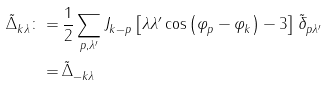<formula> <loc_0><loc_0><loc_500><loc_500>\tilde { \Delta } ^ { \ } _ { k \lambda } \colon = & \, \frac { 1 } { 2 } \sum _ { p , \lambda ^ { \prime } } J ^ { \ } _ { k - p } \left [ \lambda \lambda ^ { \prime } \cos \left ( \varphi ^ { \ } _ { p } - \varphi ^ { \ } _ { k } \right ) - 3 \right ] \tilde { \delta } ^ { \ } _ { p \lambda ^ { \prime } } \\ = & \, \tilde { \Delta } ^ { \ } _ { - k \lambda }</formula> 